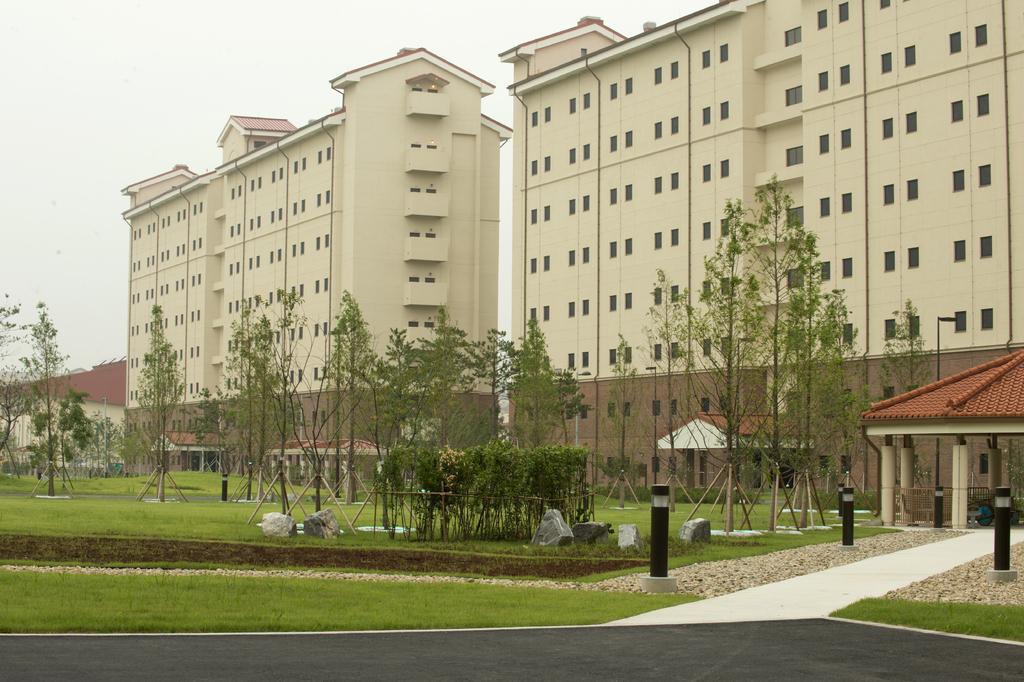How would you summarize this image in a sentence or two? In this image I can see buildings. In-front of that buildings there are trees, open-shed, lights, pillars, grass and rocks. In the background there is a sky. 